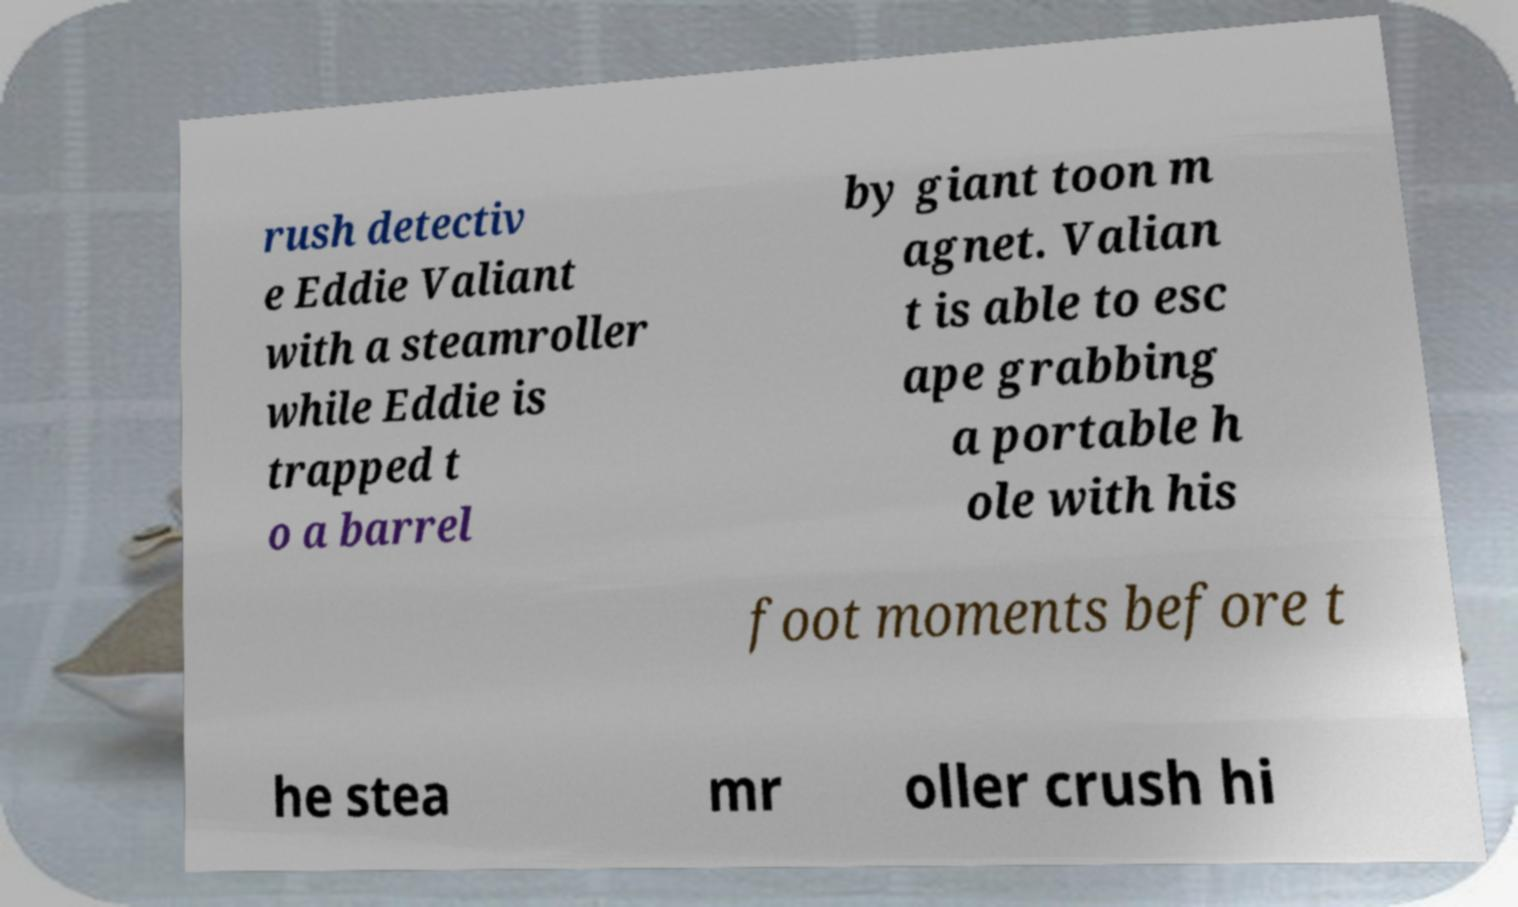Could you extract and type out the text from this image? rush detectiv e Eddie Valiant with a steamroller while Eddie is trapped t o a barrel by giant toon m agnet. Valian t is able to esc ape grabbing a portable h ole with his foot moments before t he stea mr oller crush hi 